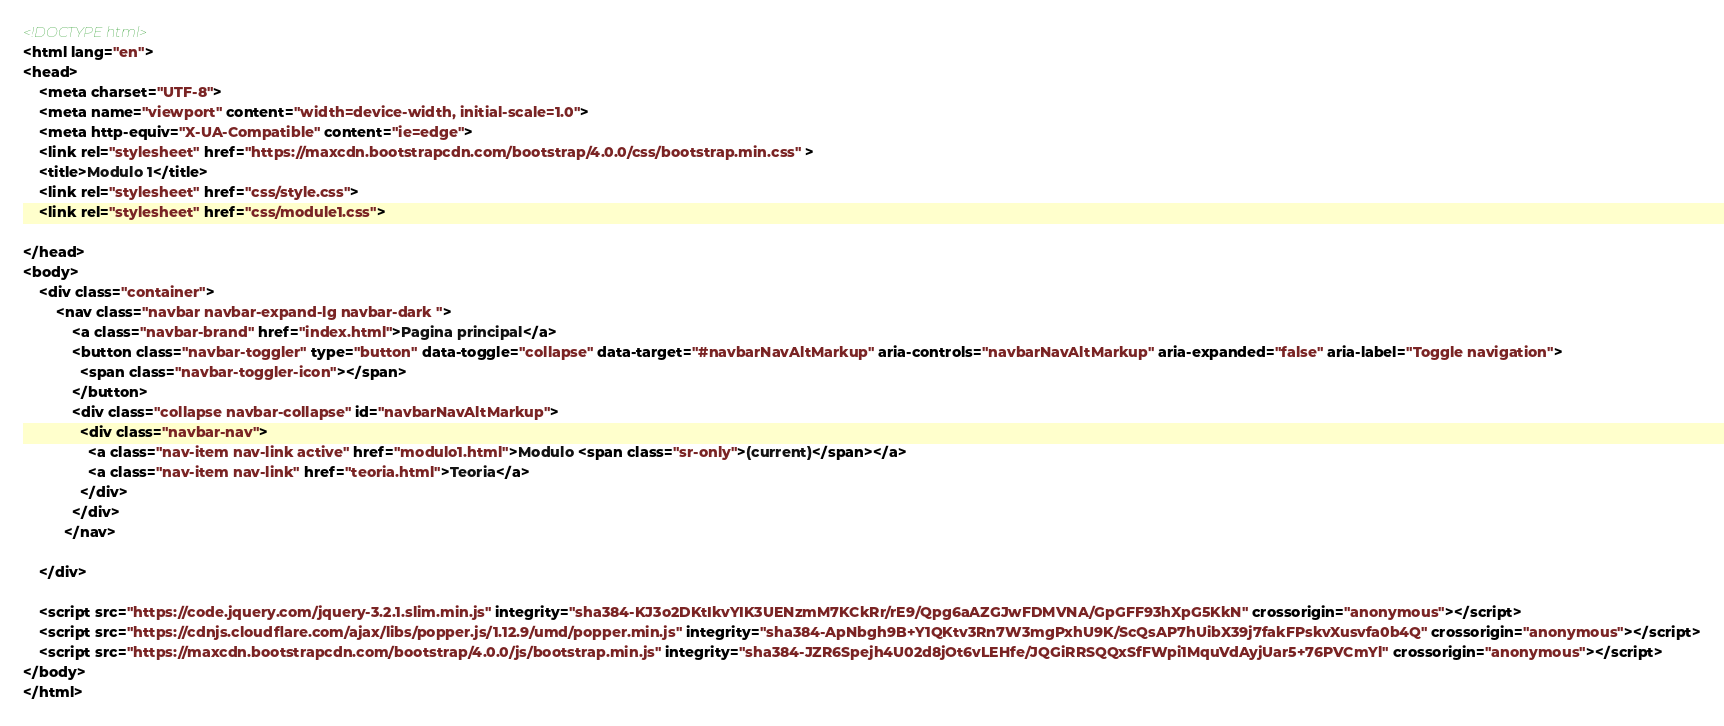<code> <loc_0><loc_0><loc_500><loc_500><_HTML_><!DOCTYPE html>
<html lang="en">
<head>
    <meta charset="UTF-8">
    <meta name="viewport" content="width=device-width, initial-scale=1.0">
    <meta http-equiv="X-UA-Compatible" content="ie=edge">
    <link rel="stylesheet" href="https://maxcdn.bootstrapcdn.com/bootstrap/4.0.0/css/bootstrap.min.css" >
    <title>Modulo 1</title>
    <link rel="stylesheet" href="css/style.css">
    <link rel="stylesheet" href="css/module1.css">
    
</head>
<body>
    <div class="container">
        <nav class="navbar navbar-expand-lg navbar-dark ">
            <a class="navbar-brand" href="index.html">Pagina principal</a>
            <button class="navbar-toggler" type="button" data-toggle="collapse" data-target="#navbarNavAltMarkup" aria-controls="navbarNavAltMarkup" aria-expanded="false" aria-label="Toggle navigation">
              <span class="navbar-toggler-icon"></span>
            </button>
            <div class="collapse navbar-collapse" id="navbarNavAltMarkup">
              <div class="navbar-nav">
                <a class="nav-item nav-link active" href="modulo1.html">Modulo <span class="sr-only">(current)</span></a>
                <a class="nav-item nav-link" href="teoria.html">Teoria</a>
              </div>
            </div>
          </nav>
          
    </div>

    <script src="https://code.jquery.com/jquery-3.2.1.slim.min.js" integrity="sha384-KJ3o2DKtIkvYIK3UENzmM7KCkRr/rE9/Qpg6aAZGJwFDMVNA/GpGFF93hXpG5KkN" crossorigin="anonymous"></script>
    <script src="https://cdnjs.cloudflare.com/ajax/libs/popper.js/1.12.9/umd/popper.min.js" integrity="sha384-ApNbgh9B+Y1QKtv3Rn7W3mgPxhU9K/ScQsAP7hUibX39j7fakFPskvXusvfa0b4Q" crossorigin="anonymous"></script>
    <script src="https://maxcdn.bootstrapcdn.com/bootstrap/4.0.0/js/bootstrap.min.js" integrity="sha384-JZR6Spejh4U02d8jOt6vLEHfe/JQGiRRSQQxSfFWpi1MquVdAyjUar5+76PVCmYl" crossorigin="anonymous"></script>
</body>
</html></code> 